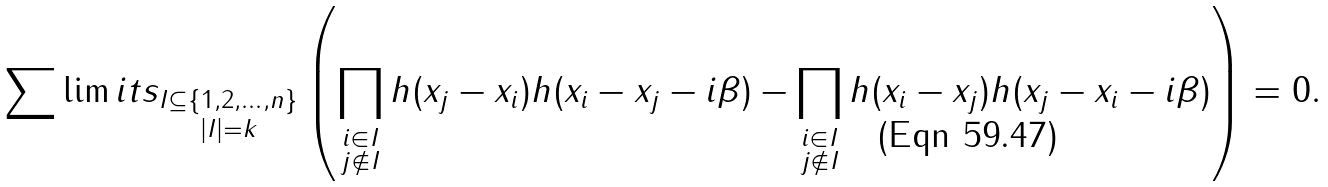<formula> <loc_0><loc_0><loc_500><loc_500>\sum \lim i t s _ { \substack { I \subseteq \{ 1 , 2 , \dots , n \} \\ | I | = k } } \left ( \prod _ { \substack { i \in I \\ { j \not \in I } } } h ( x _ { j } - x _ { i } ) h ( x _ { i } - x _ { j } - i \beta ) - \prod _ { \substack { i \in I \\ { j \not \in I } } } h ( x _ { i } - x _ { j } ) h ( x _ { j } - x _ { i } - i \beta ) \right ) = 0 .</formula> 